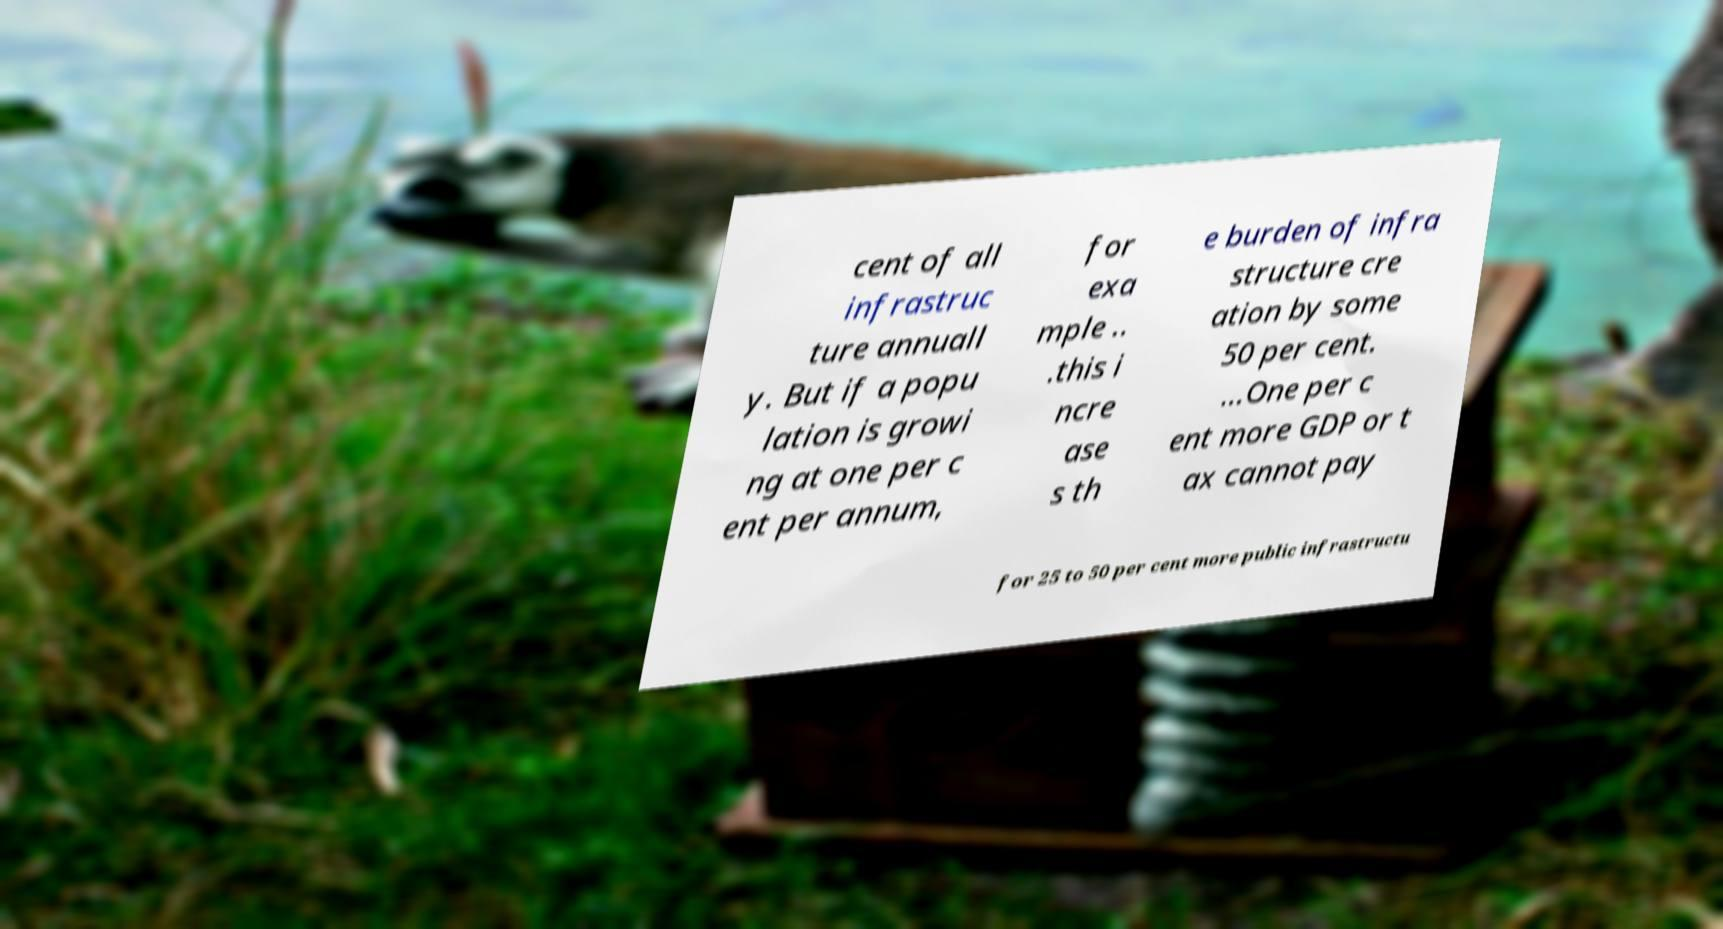Can you read and provide the text displayed in the image?This photo seems to have some interesting text. Can you extract and type it out for me? cent of all infrastruc ture annuall y. But if a popu lation is growi ng at one per c ent per annum, for exa mple .. .this i ncre ase s th e burden of infra structure cre ation by some 50 per cent. ...One per c ent more GDP or t ax cannot pay for 25 to 50 per cent more public infrastructu 